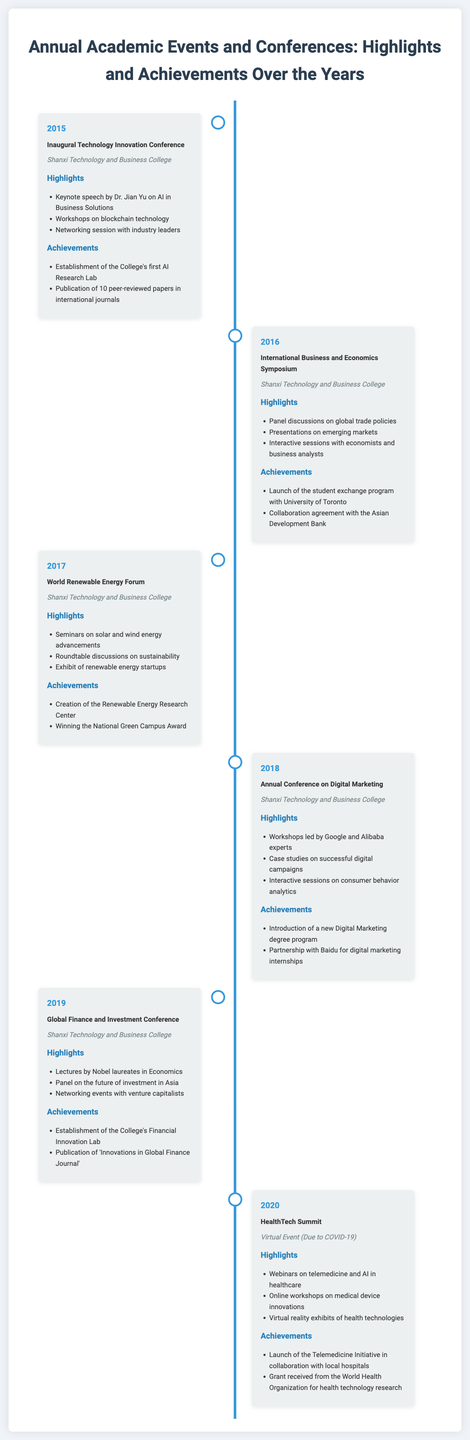What was the first event in the timeline? The first event listed in the timeline is the Inaugural Technology Innovation Conference held in 2015.
Answer: Inaugural Technology Innovation Conference Who gave the keynote speech at the 2015 conference? The keynote speech at the 2015 conference was given by Dr. Jian Yu.
Answer: Dr. Jian Yu What year was the Renewable Energy Research Center established? The Renewable Energy Research Center was established following the World Renewable Energy Forum in 2017.
Answer: 2017 How many peer-reviewed papers were published in 2015? In 2015, 10 peer-reviewed papers were published in international journals.
Answer: 10 What is the location of the 2020 HealthTech Summit? The HealthTech Summit in 2020 was a virtual event due to COVID-19.
Answer: Virtual Event Which organization provided a grant for health technology research in 2020? The grant for health technology research in 2020 was received from the World Health Organization.
Answer: World Health Organization What was introduced in 2018 related to Digital Marketing? A new Digital Marketing degree program was introduced in 2018.
Answer: Digital Marketing degree program Which event included seminars on solar and wind energy advances? The World Renewable Energy Forum in 2017 included seminars on solar and wind energy advancements.
Answer: World Renewable Energy Forum How many workshops were mentioned in the highlights of the HealthTech Summit? There were three types of webinars and workshops mentioned for the HealthTech Summit in 2020.
Answer: Three 